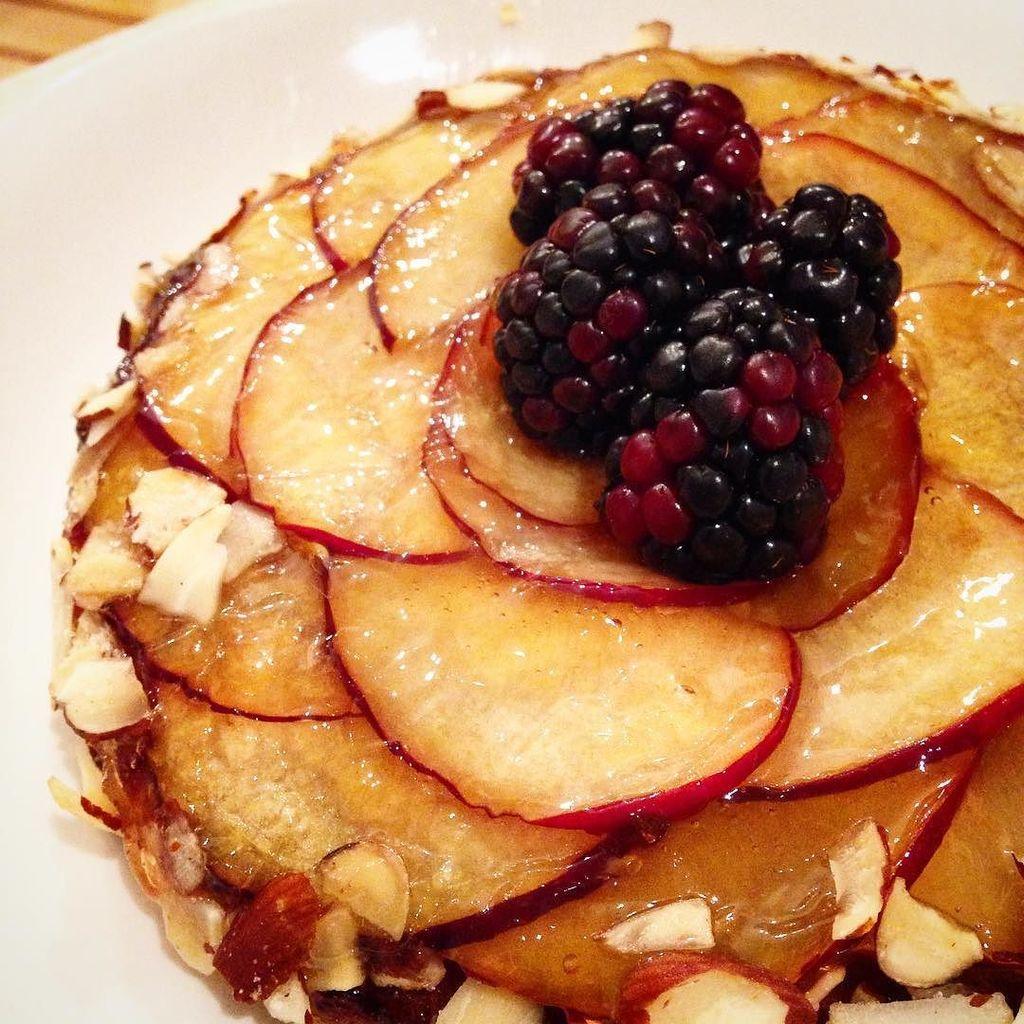Could you give a brief overview of what you see in this image? In this picture I can see food in the plate and I can see few berries. 